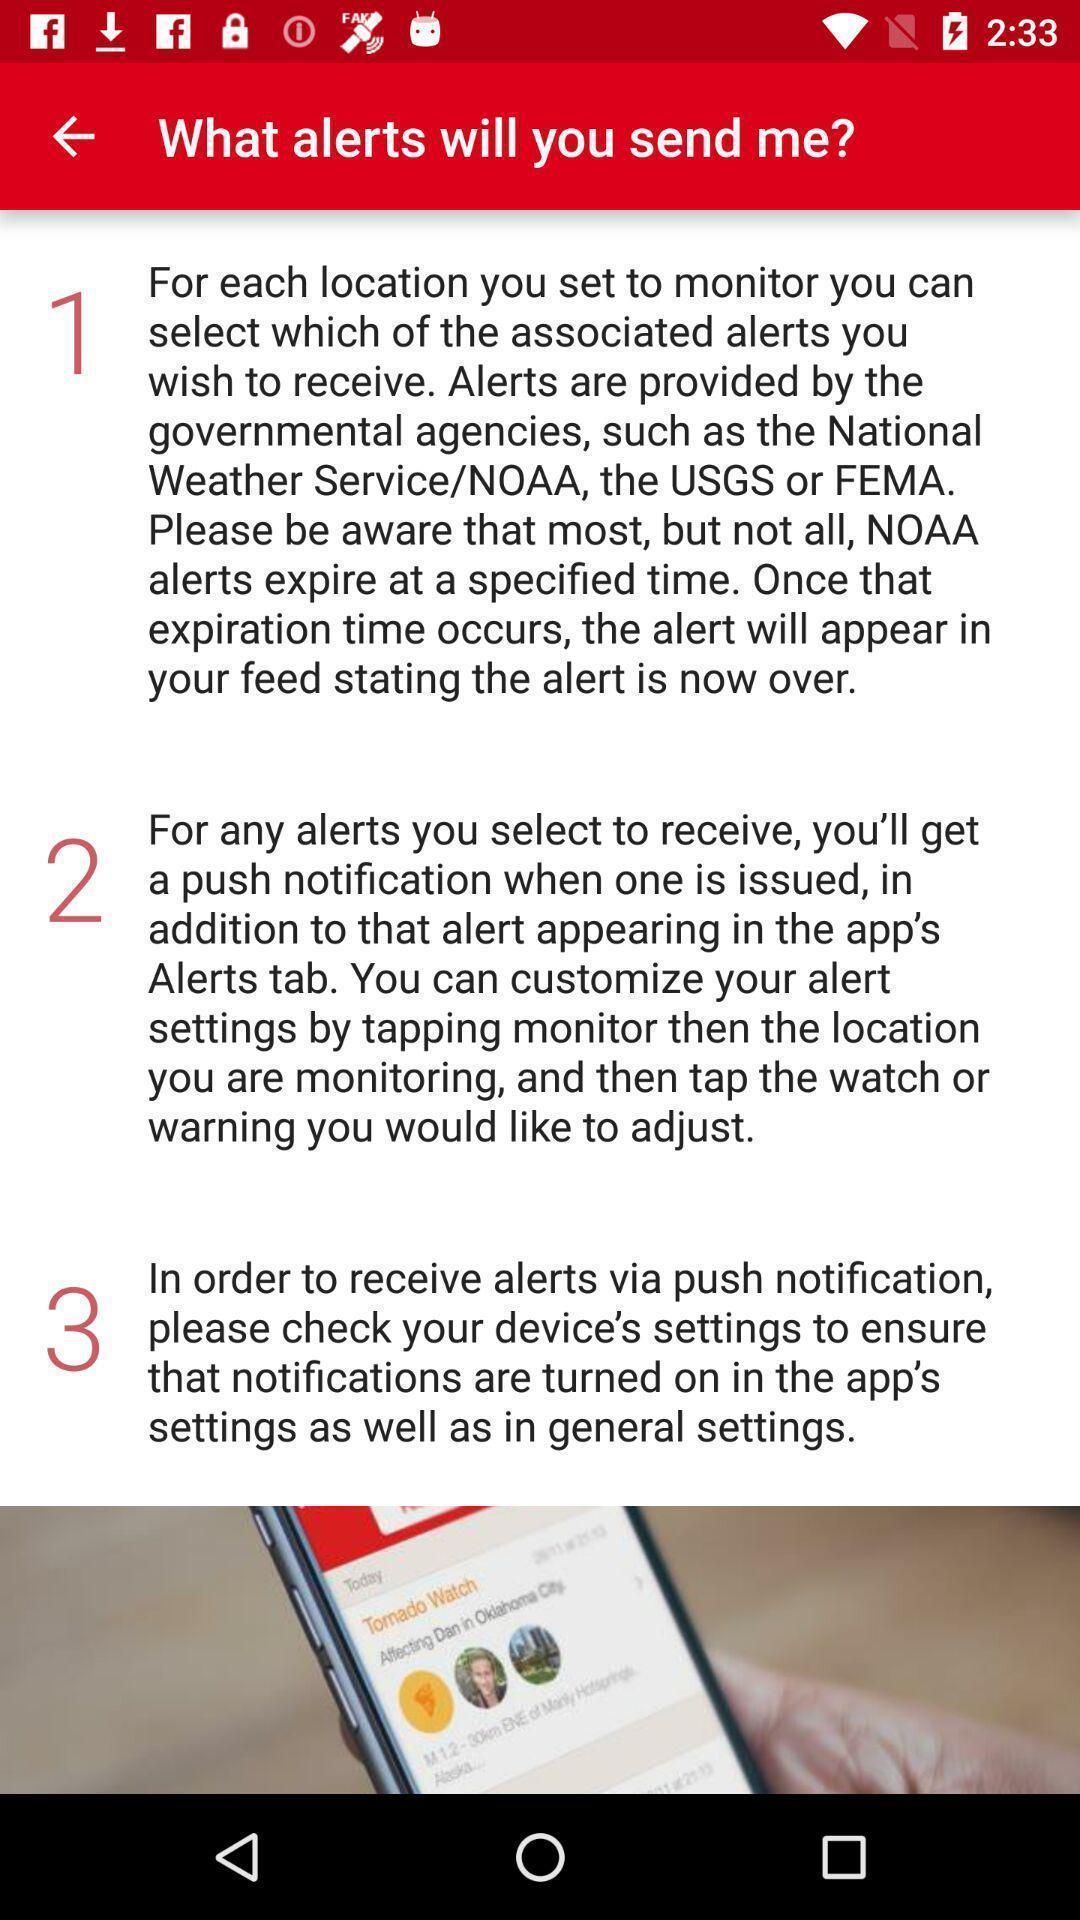Describe the content in this image. Page showing information about notifications. 